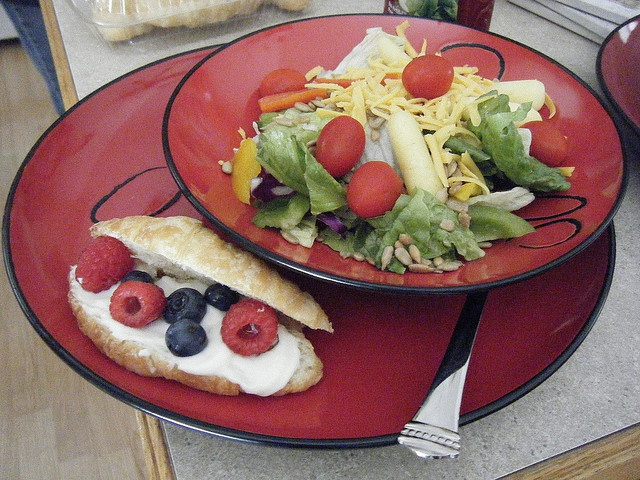Describe the objects in this image and their specific colors. I can see bowl in black, brown, khaki, and olive tones, sandwich in black, lightgray, brown, tan, and darkgray tones, fork in black, lightgray, darkgray, and gray tones, spoon in black, lightgray, darkgray, and gray tones, and carrot in black, red, tan, salmon, and brown tones in this image. 